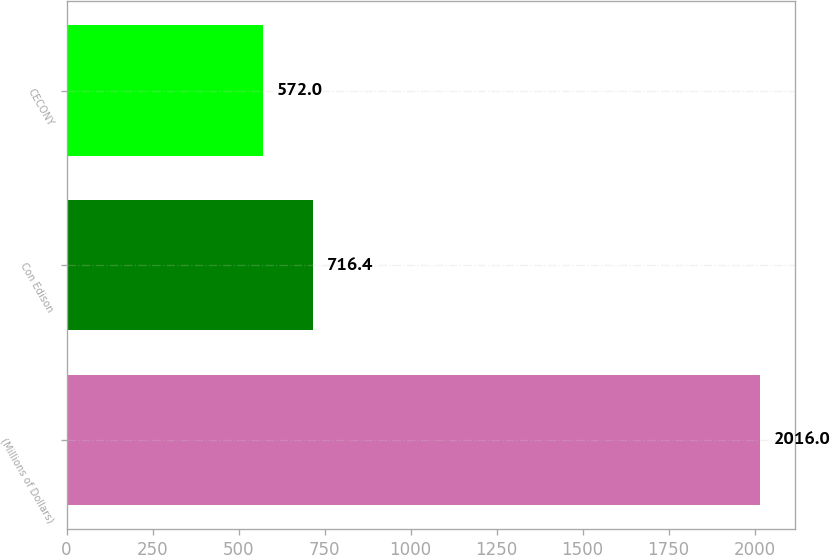Convert chart. <chart><loc_0><loc_0><loc_500><loc_500><bar_chart><fcel>(Millions of Dollars)<fcel>Con Edison<fcel>CECONY<nl><fcel>2016<fcel>716.4<fcel>572<nl></chart> 